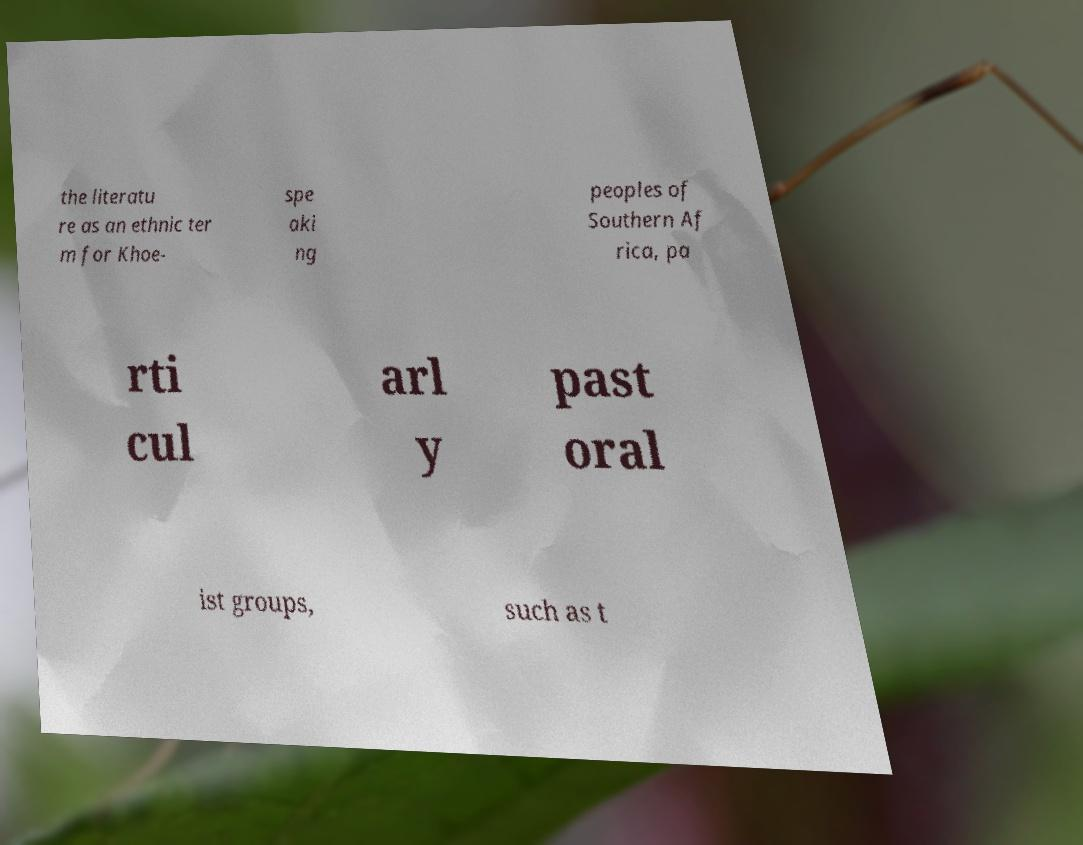I need the written content from this picture converted into text. Can you do that? the literatu re as an ethnic ter m for Khoe- spe aki ng peoples of Southern Af rica, pa rti cul arl y past oral ist groups, such as t 